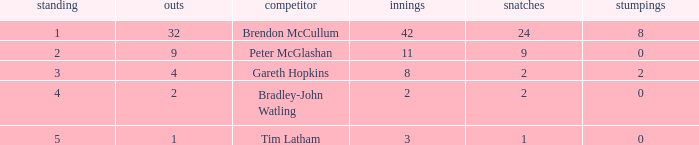List the ranks of all dismissals with a value of 4 3.0. 